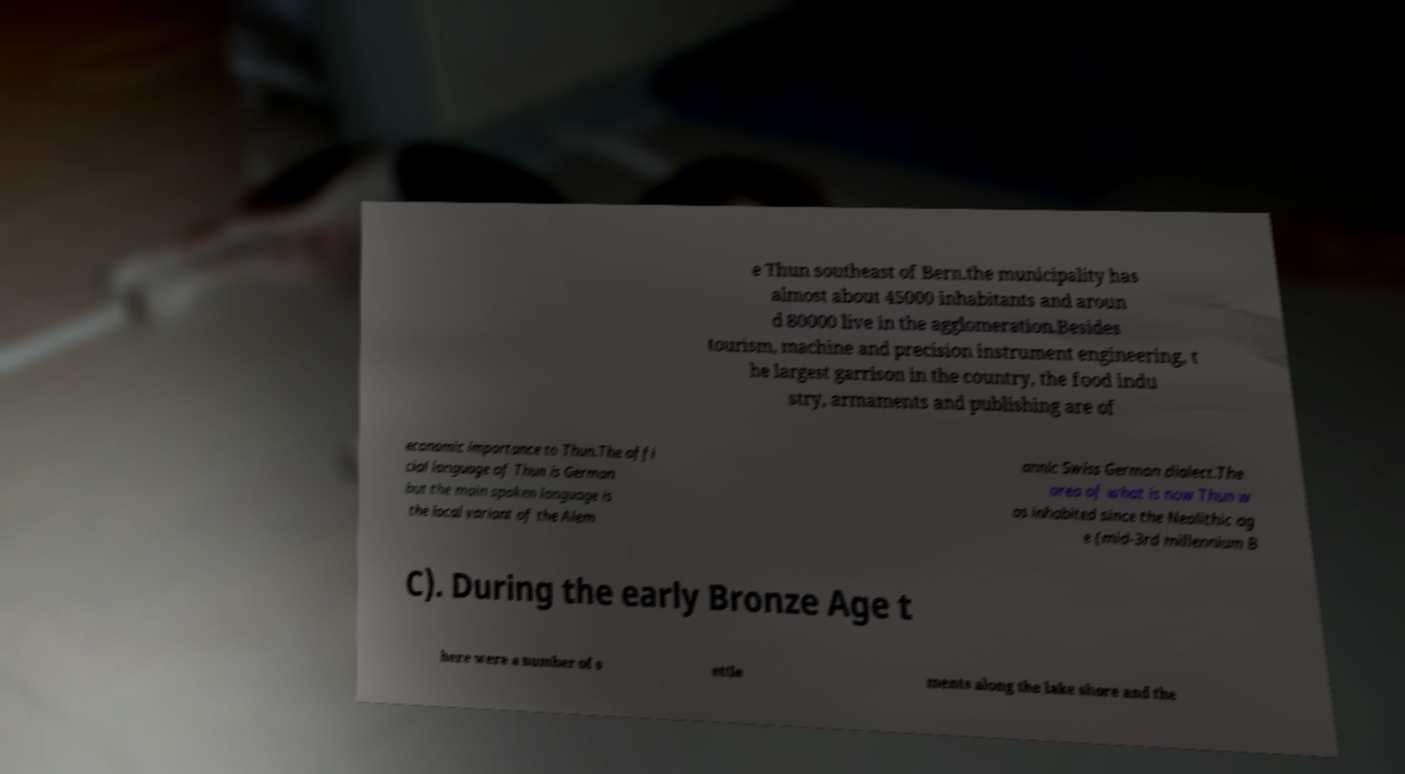Please read and relay the text visible in this image. What does it say? e Thun southeast of Bern.the municipality has almost about 45000 inhabitants and aroun d 80000 live in the agglomeration.Besides tourism, machine and precision instrument engineering, t he largest garrison in the country, the food indu stry, armaments and publishing are of economic importance to Thun.The offi cial language of Thun is German but the main spoken language is the local variant of the Alem annic Swiss German dialect.The area of what is now Thun w as inhabited since the Neolithic ag e (mid-3rd millennium B C). During the early Bronze Age t here were a number of s ettle ments along the lake shore and the 